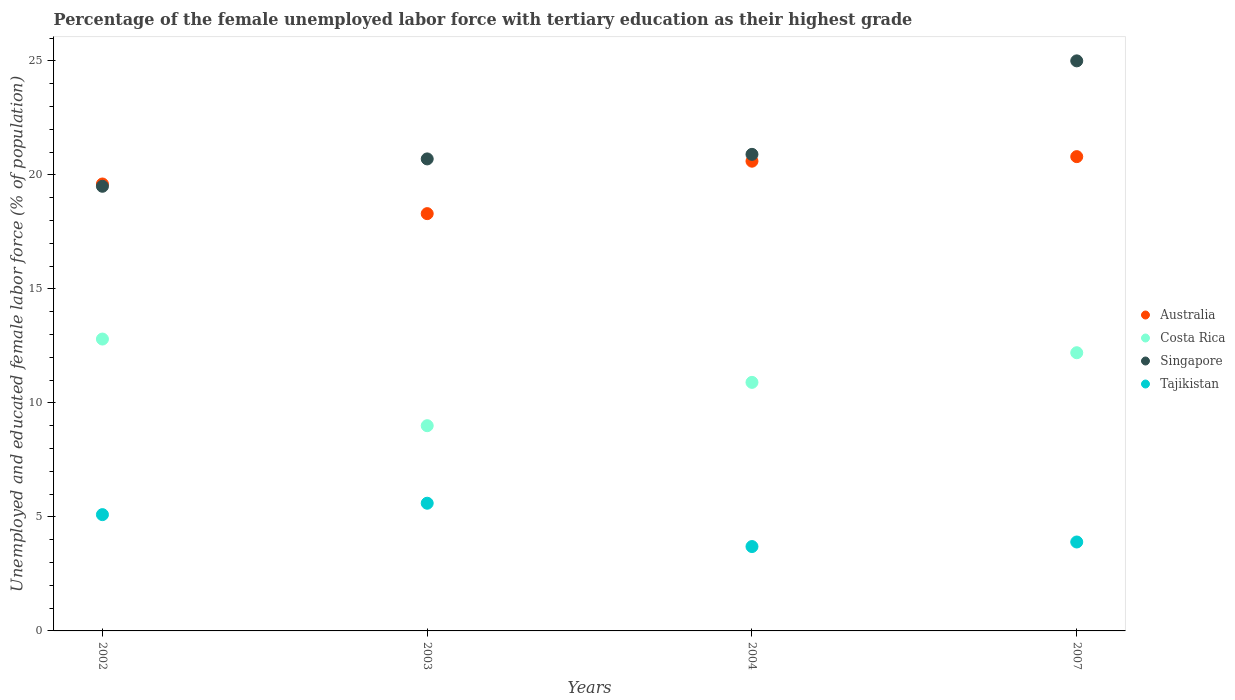What is the percentage of the unemployed female labor force with tertiary education in Costa Rica in 2004?
Your answer should be very brief. 10.9. Across all years, what is the maximum percentage of the unemployed female labor force with tertiary education in Tajikistan?
Your response must be concise. 5.6. Across all years, what is the minimum percentage of the unemployed female labor force with tertiary education in Tajikistan?
Your answer should be very brief. 3.7. In which year was the percentage of the unemployed female labor force with tertiary education in Costa Rica maximum?
Ensure brevity in your answer.  2002. In which year was the percentage of the unemployed female labor force with tertiary education in Costa Rica minimum?
Offer a terse response. 2003. What is the total percentage of the unemployed female labor force with tertiary education in Singapore in the graph?
Your answer should be very brief. 86.1. What is the difference between the percentage of the unemployed female labor force with tertiary education in Costa Rica in 2004 and that in 2007?
Your answer should be compact. -1.3. What is the difference between the percentage of the unemployed female labor force with tertiary education in Singapore in 2003 and the percentage of the unemployed female labor force with tertiary education in Australia in 2007?
Ensure brevity in your answer.  -0.1. What is the average percentage of the unemployed female labor force with tertiary education in Australia per year?
Ensure brevity in your answer.  19.82. In the year 2004, what is the difference between the percentage of the unemployed female labor force with tertiary education in Australia and percentage of the unemployed female labor force with tertiary education in Costa Rica?
Make the answer very short. 9.7. In how many years, is the percentage of the unemployed female labor force with tertiary education in Costa Rica greater than 19 %?
Ensure brevity in your answer.  0. What is the ratio of the percentage of the unemployed female labor force with tertiary education in Tajikistan in 2003 to that in 2007?
Provide a short and direct response. 1.44. Is the percentage of the unemployed female labor force with tertiary education in Singapore in 2003 less than that in 2007?
Keep it short and to the point. Yes. What is the difference between the highest and the second highest percentage of the unemployed female labor force with tertiary education in Costa Rica?
Offer a terse response. 0.6. In how many years, is the percentage of the unemployed female labor force with tertiary education in Tajikistan greater than the average percentage of the unemployed female labor force with tertiary education in Tajikistan taken over all years?
Make the answer very short. 2. Is the sum of the percentage of the unemployed female labor force with tertiary education in Tajikistan in 2002 and 2007 greater than the maximum percentage of the unemployed female labor force with tertiary education in Costa Rica across all years?
Provide a short and direct response. No. Is it the case that in every year, the sum of the percentage of the unemployed female labor force with tertiary education in Singapore and percentage of the unemployed female labor force with tertiary education in Costa Rica  is greater than the percentage of the unemployed female labor force with tertiary education in Tajikistan?
Keep it short and to the point. Yes. Is the percentage of the unemployed female labor force with tertiary education in Tajikistan strictly greater than the percentage of the unemployed female labor force with tertiary education in Costa Rica over the years?
Provide a succinct answer. No. Is the percentage of the unemployed female labor force with tertiary education in Australia strictly less than the percentage of the unemployed female labor force with tertiary education in Singapore over the years?
Provide a succinct answer. No. How many dotlines are there?
Provide a succinct answer. 4. What is the difference between two consecutive major ticks on the Y-axis?
Provide a short and direct response. 5. Does the graph contain grids?
Offer a very short reply. No. How are the legend labels stacked?
Your answer should be very brief. Vertical. What is the title of the graph?
Your response must be concise. Percentage of the female unemployed labor force with tertiary education as their highest grade. Does "Marshall Islands" appear as one of the legend labels in the graph?
Your response must be concise. No. What is the label or title of the X-axis?
Give a very brief answer. Years. What is the label or title of the Y-axis?
Your answer should be compact. Unemployed and educated female labor force (% of population). What is the Unemployed and educated female labor force (% of population) of Australia in 2002?
Ensure brevity in your answer.  19.6. What is the Unemployed and educated female labor force (% of population) in Costa Rica in 2002?
Offer a very short reply. 12.8. What is the Unemployed and educated female labor force (% of population) in Tajikistan in 2002?
Ensure brevity in your answer.  5.1. What is the Unemployed and educated female labor force (% of population) of Australia in 2003?
Provide a succinct answer. 18.3. What is the Unemployed and educated female labor force (% of population) in Costa Rica in 2003?
Provide a short and direct response. 9. What is the Unemployed and educated female labor force (% of population) of Singapore in 2003?
Make the answer very short. 20.7. What is the Unemployed and educated female labor force (% of population) of Tajikistan in 2003?
Your response must be concise. 5.6. What is the Unemployed and educated female labor force (% of population) in Australia in 2004?
Offer a very short reply. 20.6. What is the Unemployed and educated female labor force (% of population) of Costa Rica in 2004?
Offer a very short reply. 10.9. What is the Unemployed and educated female labor force (% of population) of Singapore in 2004?
Provide a short and direct response. 20.9. What is the Unemployed and educated female labor force (% of population) of Tajikistan in 2004?
Provide a short and direct response. 3.7. What is the Unemployed and educated female labor force (% of population) in Australia in 2007?
Your answer should be compact. 20.8. What is the Unemployed and educated female labor force (% of population) of Costa Rica in 2007?
Your answer should be compact. 12.2. What is the Unemployed and educated female labor force (% of population) of Singapore in 2007?
Make the answer very short. 25. What is the Unemployed and educated female labor force (% of population) in Tajikistan in 2007?
Make the answer very short. 3.9. Across all years, what is the maximum Unemployed and educated female labor force (% of population) of Australia?
Keep it short and to the point. 20.8. Across all years, what is the maximum Unemployed and educated female labor force (% of population) of Costa Rica?
Provide a short and direct response. 12.8. Across all years, what is the maximum Unemployed and educated female labor force (% of population) of Singapore?
Your answer should be very brief. 25. Across all years, what is the maximum Unemployed and educated female labor force (% of population) of Tajikistan?
Ensure brevity in your answer.  5.6. Across all years, what is the minimum Unemployed and educated female labor force (% of population) of Australia?
Offer a terse response. 18.3. Across all years, what is the minimum Unemployed and educated female labor force (% of population) of Singapore?
Offer a terse response. 19.5. Across all years, what is the minimum Unemployed and educated female labor force (% of population) in Tajikistan?
Make the answer very short. 3.7. What is the total Unemployed and educated female labor force (% of population) of Australia in the graph?
Ensure brevity in your answer.  79.3. What is the total Unemployed and educated female labor force (% of population) of Costa Rica in the graph?
Provide a short and direct response. 44.9. What is the total Unemployed and educated female labor force (% of population) of Singapore in the graph?
Your answer should be very brief. 86.1. What is the difference between the Unemployed and educated female labor force (% of population) of Singapore in 2002 and that in 2003?
Give a very brief answer. -1.2. What is the difference between the Unemployed and educated female labor force (% of population) of Tajikistan in 2002 and that in 2003?
Ensure brevity in your answer.  -0.5. What is the difference between the Unemployed and educated female labor force (% of population) of Costa Rica in 2002 and that in 2007?
Provide a short and direct response. 0.6. What is the difference between the Unemployed and educated female labor force (% of population) in Singapore in 2002 and that in 2007?
Your answer should be very brief. -5.5. What is the difference between the Unemployed and educated female labor force (% of population) of Australia in 2003 and that in 2007?
Ensure brevity in your answer.  -2.5. What is the difference between the Unemployed and educated female labor force (% of population) of Costa Rica in 2003 and that in 2007?
Provide a succinct answer. -3.2. What is the difference between the Unemployed and educated female labor force (% of population) of Australia in 2004 and that in 2007?
Offer a terse response. -0.2. What is the difference between the Unemployed and educated female labor force (% of population) in Costa Rica in 2004 and that in 2007?
Make the answer very short. -1.3. What is the difference between the Unemployed and educated female labor force (% of population) of Singapore in 2004 and that in 2007?
Provide a short and direct response. -4.1. What is the difference between the Unemployed and educated female labor force (% of population) of Tajikistan in 2004 and that in 2007?
Make the answer very short. -0.2. What is the difference between the Unemployed and educated female labor force (% of population) of Australia in 2002 and the Unemployed and educated female labor force (% of population) of Costa Rica in 2003?
Give a very brief answer. 10.6. What is the difference between the Unemployed and educated female labor force (% of population) in Australia in 2002 and the Unemployed and educated female labor force (% of population) in Singapore in 2003?
Provide a short and direct response. -1.1. What is the difference between the Unemployed and educated female labor force (% of population) in Costa Rica in 2002 and the Unemployed and educated female labor force (% of population) in Tajikistan in 2003?
Keep it short and to the point. 7.2. What is the difference between the Unemployed and educated female labor force (% of population) of Singapore in 2002 and the Unemployed and educated female labor force (% of population) of Tajikistan in 2003?
Keep it short and to the point. 13.9. What is the difference between the Unemployed and educated female labor force (% of population) in Australia in 2002 and the Unemployed and educated female labor force (% of population) in Singapore in 2004?
Provide a short and direct response. -1.3. What is the difference between the Unemployed and educated female labor force (% of population) in Costa Rica in 2002 and the Unemployed and educated female labor force (% of population) in Singapore in 2004?
Provide a short and direct response. -8.1. What is the difference between the Unemployed and educated female labor force (% of population) in Costa Rica in 2002 and the Unemployed and educated female labor force (% of population) in Tajikistan in 2004?
Your response must be concise. 9.1. What is the difference between the Unemployed and educated female labor force (% of population) of Singapore in 2002 and the Unemployed and educated female labor force (% of population) of Tajikistan in 2004?
Provide a short and direct response. 15.8. What is the difference between the Unemployed and educated female labor force (% of population) of Australia in 2002 and the Unemployed and educated female labor force (% of population) of Costa Rica in 2007?
Your response must be concise. 7.4. What is the difference between the Unemployed and educated female labor force (% of population) of Australia in 2002 and the Unemployed and educated female labor force (% of population) of Singapore in 2007?
Your answer should be compact. -5.4. What is the difference between the Unemployed and educated female labor force (% of population) in Australia in 2003 and the Unemployed and educated female labor force (% of population) in Costa Rica in 2004?
Provide a short and direct response. 7.4. What is the difference between the Unemployed and educated female labor force (% of population) in Australia in 2003 and the Unemployed and educated female labor force (% of population) in Tajikistan in 2004?
Offer a very short reply. 14.6. What is the difference between the Unemployed and educated female labor force (% of population) of Australia in 2003 and the Unemployed and educated female labor force (% of population) of Singapore in 2007?
Provide a short and direct response. -6.7. What is the difference between the Unemployed and educated female labor force (% of population) in Australia in 2003 and the Unemployed and educated female labor force (% of population) in Tajikistan in 2007?
Keep it short and to the point. 14.4. What is the difference between the Unemployed and educated female labor force (% of population) of Costa Rica in 2003 and the Unemployed and educated female labor force (% of population) of Singapore in 2007?
Your response must be concise. -16. What is the difference between the Unemployed and educated female labor force (% of population) of Costa Rica in 2004 and the Unemployed and educated female labor force (% of population) of Singapore in 2007?
Your answer should be very brief. -14.1. What is the average Unemployed and educated female labor force (% of population) of Australia per year?
Offer a very short reply. 19.82. What is the average Unemployed and educated female labor force (% of population) in Costa Rica per year?
Ensure brevity in your answer.  11.22. What is the average Unemployed and educated female labor force (% of population) of Singapore per year?
Your answer should be compact. 21.52. What is the average Unemployed and educated female labor force (% of population) in Tajikistan per year?
Give a very brief answer. 4.58. In the year 2002, what is the difference between the Unemployed and educated female labor force (% of population) of Australia and Unemployed and educated female labor force (% of population) of Costa Rica?
Ensure brevity in your answer.  6.8. In the year 2002, what is the difference between the Unemployed and educated female labor force (% of population) of Australia and Unemployed and educated female labor force (% of population) of Singapore?
Provide a short and direct response. 0.1. In the year 2002, what is the difference between the Unemployed and educated female labor force (% of population) of Australia and Unemployed and educated female labor force (% of population) of Tajikistan?
Give a very brief answer. 14.5. In the year 2002, what is the difference between the Unemployed and educated female labor force (% of population) of Costa Rica and Unemployed and educated female labor force (% of population) of Singapore?
Your answer should be very brief. -6.7. In the year 2002, what is the difference between the Unemployed and educated female labor force (% of population) of Costa Rica and Unemployed and educated female labor force (% of population) of Tajikistan?
Provide a short and direct response. 7.7. In the year 2003, what is the difference between the Unemployed and educated female labor force (% of population) of Australia and Unemployed and educated female labor force (% of population) of Costa Rica?
Ensure brevity in your answer.  9.3. In the year 2003, what is the difference between the Unemployed and educated female labor force (% of population) of Australia and Unemployed and educated female labor force (% of population) of Singapore?
Ensure brevity in your answer.  -2.4. In the year 2003, what is the difference between the Unemployed and educated female labor force (% of population) of Costa Rica and Unemployed and educated female labor force (% of population) of Singapore?
Make the answer very short. -11.7. In the year 2003, what is the difference between the Unemployed and educated female labor force (% of population) of Costa Rica and Unemployed and educated female labor force (% of population) of Tajikistan?
Make the answer very short. 3.4. In the year 2004, what is the difference between the Unemployed and educated female labor force (% of population) of Costa Rica and Unemployed and educated female labor force (% of population) of Singapore?
Provide a succinct answer. -10. In the year 2004, what is the difference between the Unemployed and educated female labor force (% of population) in Costa Rica and Unemployed and educated female labor force (% of population) in Tajikistan?
Provide a succinct answer. 7.2. In the year 2007, what is the difference between the Unemployed and educated female labor force (% of population) in Australia and Unemployed and educated female labor force (% of population) in Costa Rica?
Offer a very short reply. 8.6. In the year 2007, what is the difference between the Unemployed and educated female labor force (% of population) of Australia and Unemployed and educated female labor force (% of population) of Singapore?
Provide a short and direct response. -4.2. In the year 2007, what is the difference between the Unemployed and educated female labor force (% of population) in Australia and Unemployed and educated female labor force (% of population) in Tajikistan?
Keep it short and to the point. 16.9. In the year 2007, what is the difference between the Unemployed and educated female labor force (% of population) of Singapore and Unemployed and educated female labor force (% of population) of Tajikistan?
Offer a terse response. 21.1. What is the ratio of the Unemployed and educated female labor force (% of population) of Australia in 2002 to that in 2003?
Provide a succinct answer. 1.07. What is the ratio of the Unemployed and educated female labor force (% of population) in Costa Rica in 2002 to that in 2003?
Offer a very short reply. 1.42. What is the ratio of the Unemployed and educated female labor force (% of population) in Singapore in 2002 to that in 2003?
Provide a succinct answer. 0.94. What is the ratio of the Unemployed and educated female labor force (% of population) of Tajikistan in 2002 to that in 2003?
Give a very brief answer. 0.91. What is the ratio of the Unemployed and educated female labor force (% of population) in Australia in 2002 to that in 2004?
Offer a terse response. 0.95. What is the ratio of the Unemployed and educated female labor force (% of population) in Costa Rica in 2002 to that in 2004?
Offer a very short reply. 1.17. What is the ratio of the Unemployed and educated female labor force (% of population) of Singapore in 2002 to that in 2004?
Make the answer very short. 0.93. What is the ratio of the Unemployed and educated female labor force (% of population) of Tajikistan in 2002 to that in 2004?
Give a very brief answer. 1.38. What is the ratio of the Unemployed and educated female labor force (% of population) in Australia in 2002 to that in 2007?
Give a very brief answer. 0.94. What is the ratio of the Unemployed and educated female labor force (% of population) of Costa Rica in 2002 to that in 2007?
Provide a short and direct response. 1.05. What is the ratio of the Unemployed and educated female labor force (% of population) of Singapore in 2002 to that in 2007?
Your answer should be compact. 0.78. What is the ratio of the Unemployed and educated female labor force (% of population) of Tajikistan in 2002 to that in 2007?
Offer a terse response. 1.31. What is the ratio of the Unemployed and educated female labor force (% of population) of Australia in 2003 to that in 2004?
Provide a succinct answer. 0.89. What is the ratio of the Unemployed and educated female labor force (% of population) in Costa Rica in 2003 to that in 2004?
Your response must be concise. 0.83. What is the ratio of the Unemployed and educated female labor force (% of population) of Tajikistan in 2003 to that in 2004?
Provide a short and direct response. 1.51. What is the ratio of the Unemployed and educated female labor force (% of population) in Australia in 2003 to that in 2007?
Provide a succinct answer. 0.88. What is the ratio of the Unemployed and educated female labor force (% of population) of Costa Rica in 2003 to that in 2007?
Provide a succinct answer. 0.74. What is the ratio of the Unemployed and educated female labor force (% of population) of Singapore in 2003 to that in 2007?
Your answer should be compact. 0.83. What is the ratio of the Unemployed and educated female labor force (% of population) in Tajikistan in 2003 to that in 2007?
Provide a succinct answer. 1.44. What is the ratio of the Unemployed and educated female labor force (% of population) in Costa Rica in 2004 to that in 2007?
Ensure brevity in your answer.  0.89. What is the ratio of the Unemployed and educated female labor force (% of population) in Singapore in 2004 to that in 2007?
Your answer should be compact. 0.84. What is the ratio of the Unemployed and educated female labor force (% of population) of Tajikistan in 2004 to that in 2007?
Ensure brevity in your answer.  0.95. What is the difference between the highest and the second highest Unemployed and educated female labor force (% of population) in Costa Rica?
Your answer should be very brief. 0.6. What is the difference between the highest and the second highest Unemployed and educated female labor force (% of population) in Tajikistan?
Your response must be concise. 0.5. What is the difference between the highest and the lowest Unemployed and educated female labor force (% of population) in Australia?
Your response must be concise. 2.5. What is the difference between the highest and the lowest Unemployed and educated female labor force (% of population) in Costa Rica?
Your response must be concise. 3.8. What is the difference between the highest and the lowest Unemployed and educated female labor force (% of population) of Singapore?
Give a very brief answer. 5.5. 